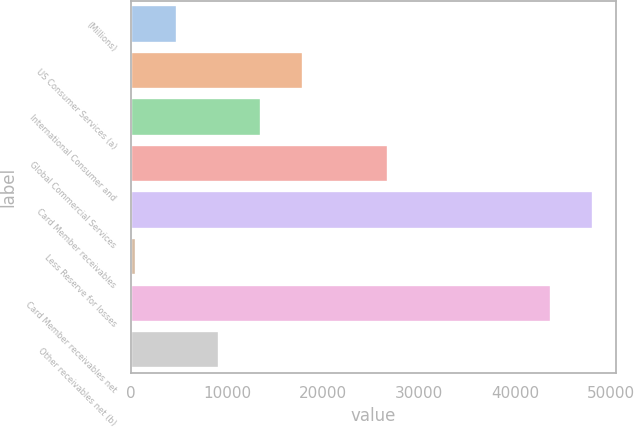Convert chart to OTSL. <chart><loc_0><loc_0><loc_500><loc_500><bar_chart><fcel>(Millions)<fcel>US Consumer Services (a)<fcel>International Consumer and<fcel>Global Commercial Services<fcel>Card Member receivables<fcel>Less Reserve for losses<fcel>Card Member receivables net<fcel>Other receivables net (b)<nl><fcel>4829.1<fcel>17930.4<fcel>13563.3<fcel>26727<fcel>48038.1<fcel>462<fcel>43671<fcel>9196.2<nl></chart> 